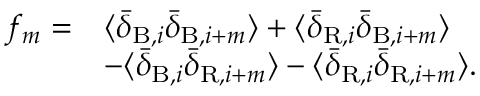Convert formula to latex. <formula><loc_0><loc_0><loc_500><loc_500>\begin{array} { r l } { f _ { m } = } & { \langle \bar { \delta } _ { B , i } \bar { \delta } _ { B , i + m } \rangle + \langle \bar { \delta } _ { R , i } \bar { \delta } _ { B , i + m } \rangle } \\ & { - \langle \bar { \delta } _ { B , i } \bar { \delta } _ { R , i + m } \rangle - \langle \bar { \delta } _ { R , i } \bar { \delta } _ { R , i + m } \rangle . } \end{array}</formula> 